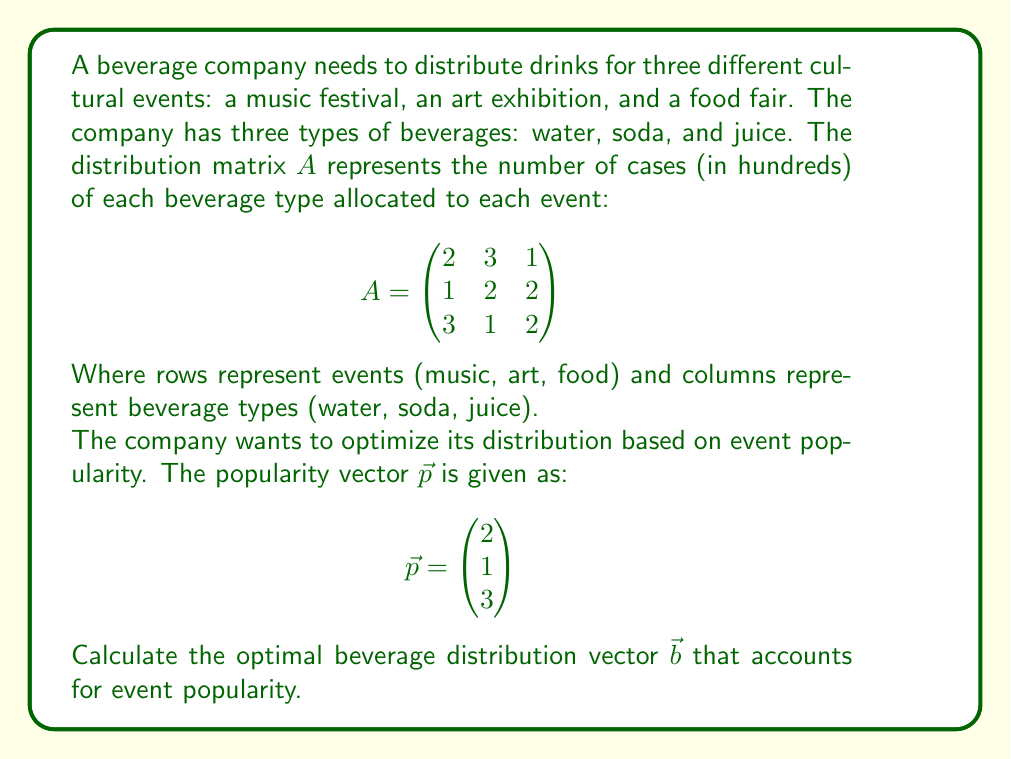Provide a solution to this math problem. To solve this problem, we need to use matrix multiplication to combine the distribution matrix with the popularity vector. This will give us the optimal beverage distribution vector.

Step 1: Set up the matrix multiplication
We need to calculate $A^T \vec{p}$, where $A^T$ is the transpose of matrix $A$.

$$A^T = \begin{pmatrix}
2 & 1 & 3 \\
3 & 2 & 1 \\
1 & 2 & 2
\end{pmatrix}$$

Step 2: Perform the matrix multiplication
$$\vec{b} = A^T \vec{p} = \begin{pmatrix}
2 & 1 & 3 \\
3 & 2 & 1 \\
1 & 2 & 2
\end{pmatrix} \begin{pmatrix}
2 \\ 1 \\ 3
\end{pmatrix}$$

Step 3: Calculate each element of the resulting vector
$b_1 = 2(2) + 1(1) + 3(3) = 4 + 1 + 9 = 14$
$b_2 = 3(2) + 2(1) + 1(3) = 6 + 2 + 3 = 11$
$b_3 = 1(2) + 2(1) + 2(3) = 2 + 2 + 6 = 10$

Step 4: Write the final vector
$$\vec{b} = \begin{pmatrix}
14 \\ 11 \\ 10
\end{pmatrix}$$

This vector represents the optimal number of cases (in hundreds) for each beverage type, taking into account the event popularity.
Answer: $$\vec{b} = \begin{pmatrix}
14 \\ 11 \\ 10
\end{pmatrix}$$ 